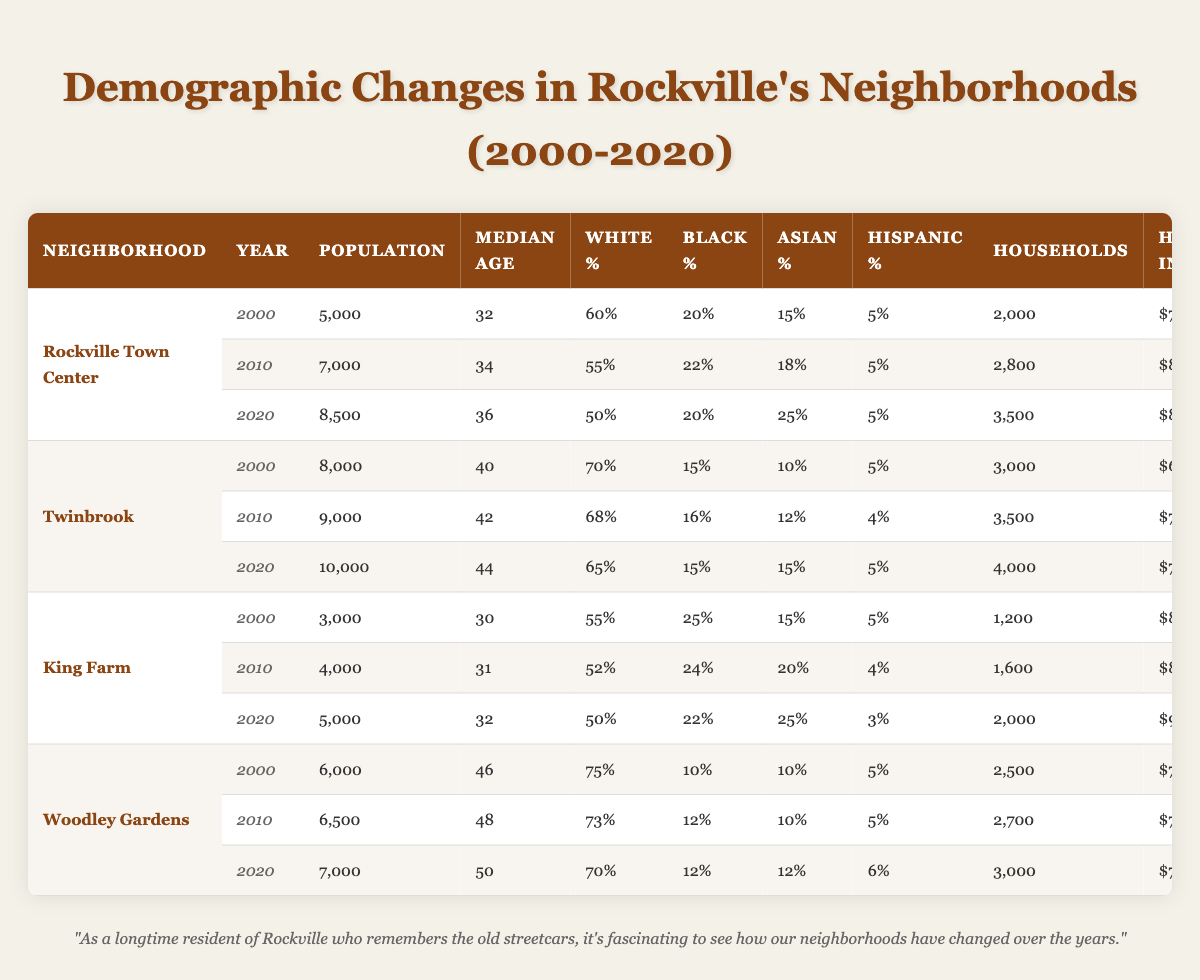What was the population of Rockville Town Center in 2010? In the table, under the row for Rockville Town Center in the year 2010, the population is listed as 7,000.
Answer: 7,000 What percentage of the population in Twinbrook was Black in 2020? Looking at the 2020 row for Twinbrook, the Black Percentage is listed as 15%.
Answer: 15% Which neighborhood had the highest median age in 2000? Reviewing the 2000 data, Woodley Gardens has the highest median age at 46 years.
Answer: Woodley Gardens In which year did King Farm experience the largest increase in household income? Looking at King Farm's household income from 2000 ($80,000) to 2010 ($85,000) and then to 2020 ($90,000), the largest increase occurred between 2010 and 2020 ($90,000 - $85,000 = $5,000).
Answer: 2010 to 2020 What is the total population of Twinbrook from 2000 to 2020? For Twinbrook, the populations are 8,000 (2000), 9,000 (2010), and 10,000 (2020). Adding these gives 8,000 + 9,000 + 10,000 = 27,000.
Answer: 27,000 Did the proportion of Hispanic residents in Rockville Town Center change between 2000 and 2020? In 2000, the Hispanic Percentage was 5%, and it remains the same in 2020. Therefore, there was no change.
Answer: No change What is the difference in median age between Woodley Gardens in 2000 and in 2020? The median age for Woodley Gardens in 2000 is 46 years and in 2020 is 50 years. The difference is 50 - 46 = 4 years.
Answer: 4 years Which neighborhood had the highest population growth from 2000 to 2020? Comparing the population growth: Rockville Town Center (3,500), Twinbrook (2,000), King Farm (2,000), and Woodley Gardens (1,000). Rockville Town Center had the highest growth of 3,500.
Answer: Rockville Town Center What is the average household income for all neighborhoods in 2020? The household incomes in 2020 are $85,000 (Rockville Town Center), $75,000 (Twinbrook), $90,000 (King Farm), and $75,000 (Woodley Gardens). The total is $85,000 + $75,000 + $90,000 + $75,000 = $325,000. The average is $325,000 / 4 = $81,250.
Answer: $81,250 Was there any neighborhood that had an Asian population percentage greater than 20% in 2020? In the 2020 data, only King Farm (25%) fits this criterion.
Answer: Yes, King Farm 